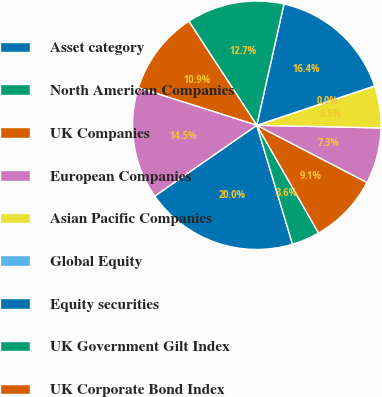Convert chart to OTSL. <chart><loc_0><loc_0><loc_500><loc_500><pie_chart><fcel>Asset category<fcel>North American Companies<fcel>UK Companies<fcel>European Companies<fcel>Asian Pacific Companies<fcel>Global Equity<fcel>Equity securities<fcel>UK Government Gilt Index<fcel>UK Corporate Bond Index<fcel>Global Fixed Income Bond<nl><fcel>19.99%<fcel>3.64%<fcel>9.09%<fcel>7.28%<fcel>5.46%<fcel>0.01%<fcel>16.36%<fcel>12.72%<fcel>10.91%<fcel>14.54%<nl></chart> 